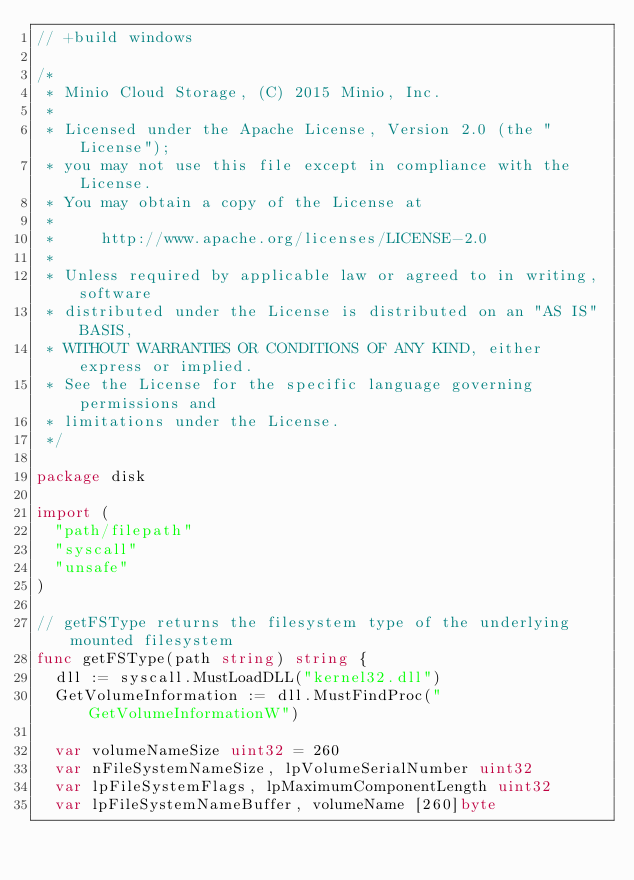Convert code to text. <code><loc_0><loc_0><loc_500><loc_500><_Go_>// +build windows

/*
 * Minio Cloud Storage, (C) 2015 Minio, Inc.
 *
 * Licensed under the Apache License, Version 2.0 (the "License");
 * you may not use this file except in compliance with the License.
 * You may obtain a copy of the License at
 *
 *     http://www.apache.org/licenses/LICENSE-2.0
 *
 * Unless required by applicable law or agreed to in writing, software
 * distributed under the License is distributed on an "AS IS" BASIS,
 * WITHOUT WARRANTIES OR CONDITIONS OF ANY KIND, either express or implied.
 * See the License for the specific language governing permissions and
 * limitations under the License.
 */

package disk

import (
	"path/filepath"
	"syscall"
	"unsafe"
)

// getFSType returns the filesystem type of the underlying mounted filesystem
func getFSType(path string) string {
	dll := syscall.MustLoadDLL("kernel32.dll")
	GetVolumeInformation := dll.MustFindProc("GetVolumeInformationW")

	var volumeNameSize uint32 = 260
	var nFileSystemNameSize, lpVolumeSerialNumber uint32
	var lpFileSystemFlags, lpMaximumComponentLength uint32
	var lpFileSystemNameBuffer, volumeName [260]byte</code> 